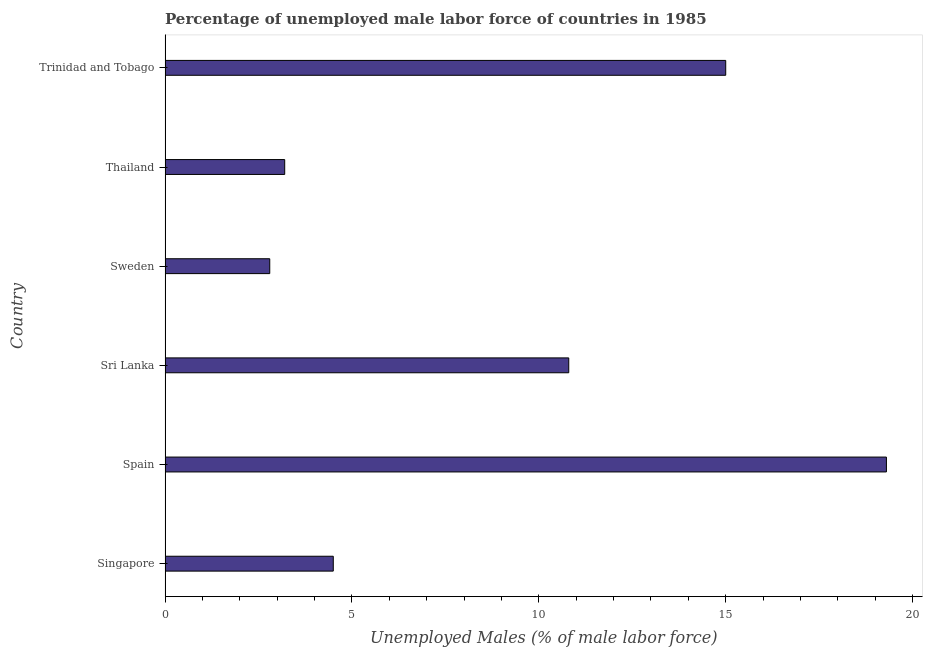What is the title of the graph?
Ensure brevity in your answer.  Percentage of unemployed male labor force of countries in 1985. What is the label or title of the X-axis?
Give a very brief answer. Unemployed Males (% of male labor force). What is the total unemployed male labour force in Thailand?
Provide a succinct answer. 3.2. Across all countries, what is the maximum total unemployed male labour force?
Your answer should be very brief. 19.3. Across all countries, what is the minimum total unemployed male labour force?
Give a very brief answer. 2.8. In which country was the total unemployed male labour force maximum?
Make the answer very short. Spain. In which country was the total unemployed male labour force minimum?
Your answer should be compact. Sweden. What is the sum of the total unemployed male labour force?
Your answer should be very brief. 55.6. What is the average total unemployed male labour force per country?
Give a very brief answer. 9.27. What is the median total unemployed male labour force?
Provide a short and direct response. 7.65. What is the ratio of the total unemployed male labour force in Sweden to that in Trinidad and Tobago?
Make the answer very short. 0.19. Is the sum of the total unemployed male labour force in Spain and Trinidad and Tobago greater than the maximum total unemployed male labour force across all countries?
Provide a succinct answer. Yes. How many countries are there in the graph?
Make the answer very short. 6. What is the Unemployed Males (% of male labor force) in Spain?
Ensure brevity in your answer.  19.3. What is the Unemployed Males (% of male labor force) in Sri Lanka?
Provide a succinct answer. 10.8. What is the Unemployed Males (% of male labor force) in Sweden?
Provide a succinct answer. 2.8. What is the Unemployed Males (% of male labor force) of Thailand?
Provide a succinct answer. 3.2. What is the Unemployed Males (% of male labor force) in Trinidad and Tobago?
Your answer should be very brief. 15. What is the difference between the Unemployed Males (% of male labor force) in Singapore and Spain?
Provide a succinct answer. -14.8. What is the difference between the Unemployed Males (% of male labor force) in Singapore and Sri Lanka?
Offer a very short reply. -6.3. What is the difference between the Unemployed Males (% of male labor force) in Singapore and Trinidad and Tobago?
Your response must be concise. -10.5. What is the difference between the Unemployed Males (% of male labor force) in Spain and Sri Lanka?
Give a very brief answer. 8.5. What is the difference between the Unemployed Males (% of male labor force) in Spain and Trinidad and Tobago?
Your answer should be very brief. 4.3. What is the difference between the Unemployed Males (% of male labor force) in Sri Lanka and Trinidad and Tobago?
Ensure brevity in your answer.  -4.2. What is the difference between the Unemployed Males (% of male labor force) in Thailand and Trinidad and Tobago?
Offer a terse response. -11.8. What is the ratio of the Unemployed Males (% of male labor force) in Singapore to that in Spain?
Provide a succinct answer. 0.23. What is the ratio of the Unemployed Males (% of male labor force) in Singapore to that in Sri Lanka?
Your response must be concise. 0.42. What is the ratio of the Unemployed Males (% of male labor force) in Singapore to that in Sweden?
Provide a succinct answer. 1.61. What is the ratio of the Unemployed Males (% of male labor force) in Singapore to that in Thailand?
Keep it short and to the point. 1.41. What is the ratio of the Unemployed Males (% of male labor force) in Spain to that in Sri Lanka?
Offer a terse response. 1.79. What is the ratio of the Unemployed Males (% of male labor force) in Spain to that in Sweden?
Provide a short and direct response. 6.89. What is the ratio of the Unemployed Males (% of male labor force) in Spain to that in Thailand?
Your answer should be very brief. 6.03. What is the ratio of the Unemployed Males (% of male labor force) in Spain to that in Trinidad and Tobago?
Offer a terse response. 1.29. What is the ratio of the Unemployed Males (% of male labor force) in Sri Lanka to that in Sweden?
Your answer should be very brief. 3.86. What is the ratio of the Unemployed Males (% of male labor force) in Sri Lanka to that in Thailand?
Give a very brief answer. 3.38. What is the ratio of the Unemployed Males (% of male labor force) in Sri Lanka to that in Trinidad and Tobago?
Your response must be concise. 0.72. What is the ratio of the Unemployed Males (% of male labor force) in Sweden to that in Trinidad and Tobago?
Give a very brief answer. 0.19. What is the ratio of the Unemployed Males (% of male labor force) in Thailand to that in Trinidad and Tobago?
Offer a very short reply. 0.21. 